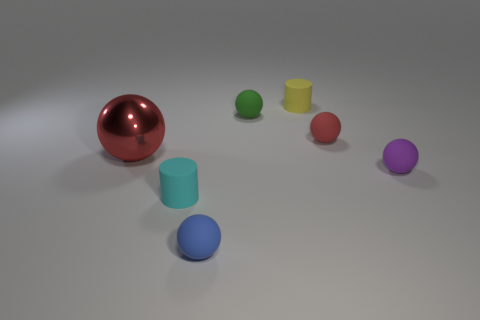Is there anything else that has the same size as the metallic thing?
Provide a succinct answer. No. There is a tiny green thing that is the same shape as the blue rubber thing; what material is it?
Give a very brief answer. Rubber. Is there a gray cylinder of the same size as the yellow matte cylinder?
Offer a terse response. No. There is a thing that is to the left of the blue rubber sphere and behind the small purple matte sphere; what material is it?
Your response must be concise. Metal. How many matte things are either blocks or cyan cylinders?
Ensure brevity in your answer.  1. There is a red thing that is made of the same material as the tiny yellow object; what is its shape?
Ensure brevity in your answer.  Sphere. What number of tiny cylinders are both in front of the yellow object and behind the tiny purple ball?
Your answer should be compact. 0. What size is the cylinder behind the tiny cyan cylinder?
Provide a short and direct response. Small. How many other objects are the same color as the metal thing?
Offer a terse response. 1. What material is the red sphere that is in front of the red thing to the right of the metallic sphere?
Provide a short and direct response. Metal. 